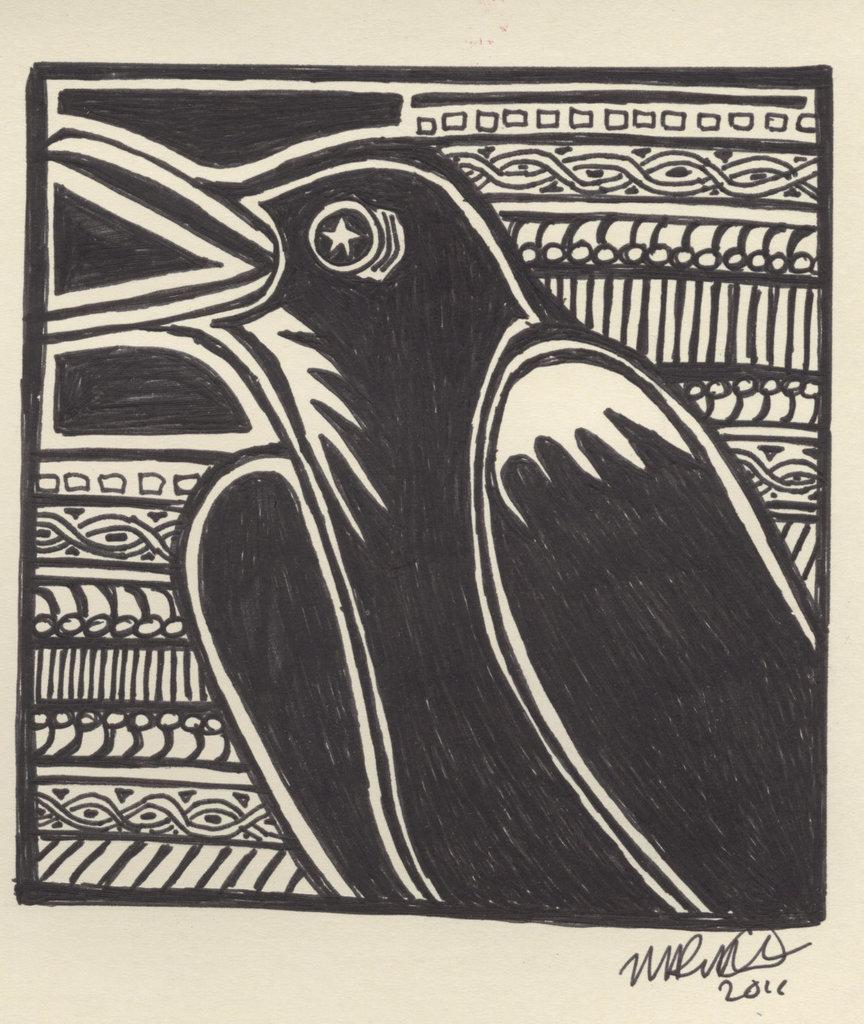What is depicted on the poster in the image? There is a sketch of a bird on a poster in the image. How many cats are hiding in the drawer in the image? There are no cats or drawers present in the image; it features a sketch of a bird on a poster. What type of drug is being advertised on the poster in the image? There is no drug or advertisement present in the image; it features a sketch of a bird on a poster. 